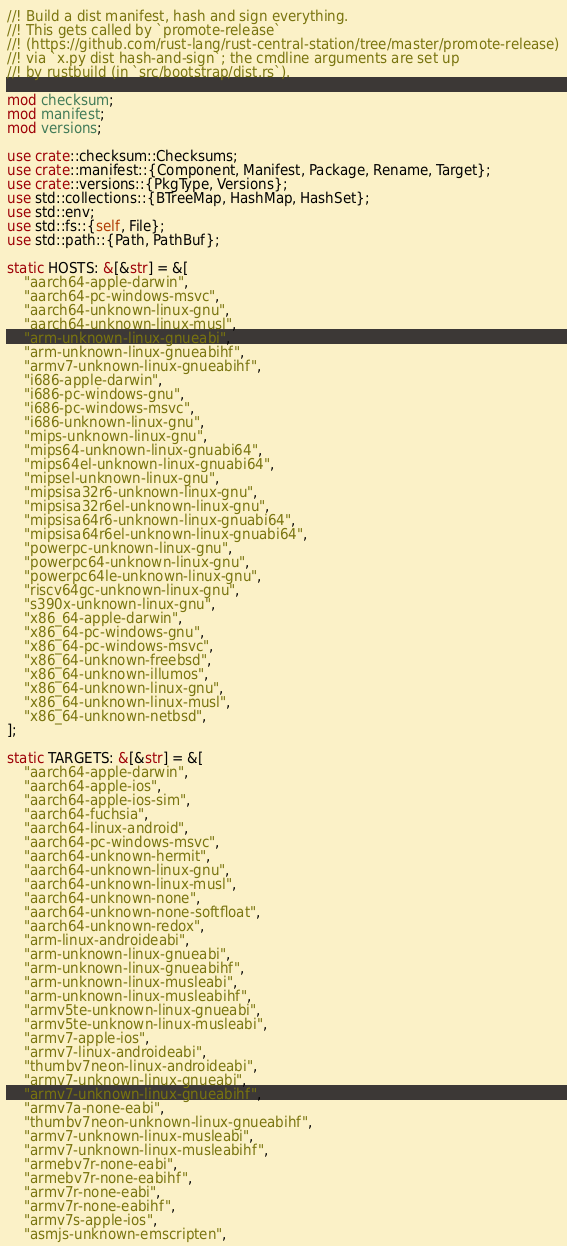<code> <loc_0><loc_0><loc_500><loc_500><_Rust_>//! Build a dist manifest, hash and sign everything.
//! This gets called by `promote-release`
//! (https://github.com/rust-lang/rust-central-station/tree/master/promote-release)
//! via `x.py dist hash-and-sign`; the cmdline arguments are set up
//! by rustbuild (in `src/bootstrap/dist.rs`).

mod checksum;
mod manifest;
mod versions;

use crate::checksum::Checksums;
use crate::manifest::{Component, Manifest, Package, Rename, Target};
use crate::versions::{PkgType, Versions};
use std::collections::{BTreeMap, HashMap, HashSet};
use std::env;
use std::fs::{self, File};
use std::path::{Path, PathBuf};

static HOSTS: &[&str] = &[
    "aarch64-apple-darwin",
    "aarch64-pc-windows-msvc",
    "aarch64-unknown-linux-gnu",
    "aarch64-unknown-linux-musl",
    "arm-unknown-linux-gnueabi",
    "arm-unknown-linux-gnueabihf",
    "armv7-unknown-linux-gnueabihf",
    "i686-apple-darwin",
    "i686-pc-windows-gnu",
    "i686-pc-windows-msvc",
    "i686-unknown-linux-gnu",
    "mips-unknown-linux-gnu",
    "mips64-unknown-linux-gnuabi64",
    "mips64el-unknown-linux-gnuabi64",
    "mipsel-unknown-linux-gnu",
    "mipsisa32r6-unknown-linux-gnu",
    "mipsisa32r6el-unknown-linux-gnu",
    "mipsisa64r6-unknown-linux-gnuabi64",
    "mipsisa64r6el-unknown-linux-gnuabi64",
    "powerpc-unknown-linux-gnu",
    "powerpc64-unknown-linux-gnu",
    "powerpc64le-unknown-linux-gnu",
    "riscv64gc-unknown-linux-gnu",
    "s390x-unknown-linux-gnu",
    "x86_64-apple-darwin",
    "x86_64-pc-windows-gnu",
    "x86_64-pc-windows-msvc",
    "x86_64-unknown-freebsd",
    "x86_64-unknown-illumos",
    "x86_64-unknown-linux-gnu",
    "x86_64-unknown-linux-musl",
    "x86_64-unknown-netbsd",
];

static TARGETS: &[&str] = &[
    "aarch64-apple-darwin",
    "aarch64-apple-ios",
    "aarch64-apple-ios-sim",
    "aarch64-fuchsia",
    "aarch64-linux-android",
    "aarch64-pc-windows-msvc",
    "aarch64-unknown-hermit",
    "aarch64-unknown-linux-gnu",
    "aarch64-unknown-linux-musl",
    "aarch64-unknown-none",
    "aarch64-unknown-none-softfloat",
    "aarch64-unknown-redox",
    "arm-linux-androideabi",
    "arm-unknown-linux-gnueabi",
    "arm-unknown-linux-gnueabihf",
    "arm-unknown-linux-musleabi",
    "arm-unknown-linux-musleabihf",
    "armv5te-unknown-linux-gnueabi",
    "armv5te-unknown-linux-musleabi",
    "armv7-apple-ios",
    "armv7-linux-androideabi",
    "thumbv7neon-linux-androideabi",
    "armv7-unknown-linux-gnueabi",
    "armv7-unknown-linux-gnueabihf",
    "armv7a-none-eabi",
    "thumbv7neon-unknown-linux-gnueabihf",
    "armv7-unknown-linux-musleabi",
    "armv7-unknown-linux-musleabihf",
    "armebv7r-none-eabi",
    "armebv7r-none-eabihf",
    "armv7r-none-eabi",
    "armv7r-none-eabihf",
    "armv7s-apple-ios",
    "asmjs-unknown-emscripten",</code> 